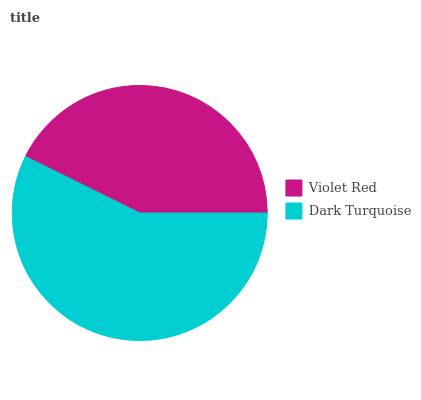Is Violet Red the minimum?
Answer yes or no. Yes. Is Dark Turquoise the maximum?
Answer yes or no. Yes. Is Dark Turquoise the minimum?
Answer yes or no. No. Is Dark Turquoise greater than Violet Red?
Answer yes or no. Yes. Is Violet Red less than Dark Turquoise?
Answer yes or no. Yes. Is Violet Red greater than Dark Turquoise?
Answer yes or no. No. Is Dark Turquoise less than Violet Red?
Answer yes or no. No. Is Dark Turquoise the high median?
Answer yes or no. Yes. Is Violet Red the low median?
Answer yes or no. Yes. Is Violet Red the high median?
Answer yes or no. No. Is Dark Turquoise the low median?
Answer yes or no. No. 